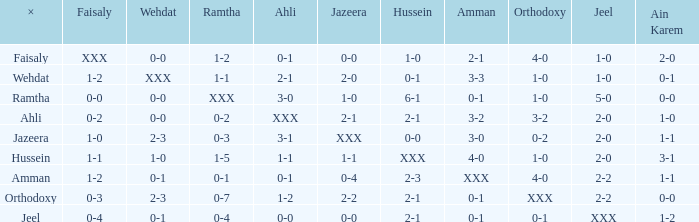What does faisaly mean when wehdat is given as xxx? 1-2. 